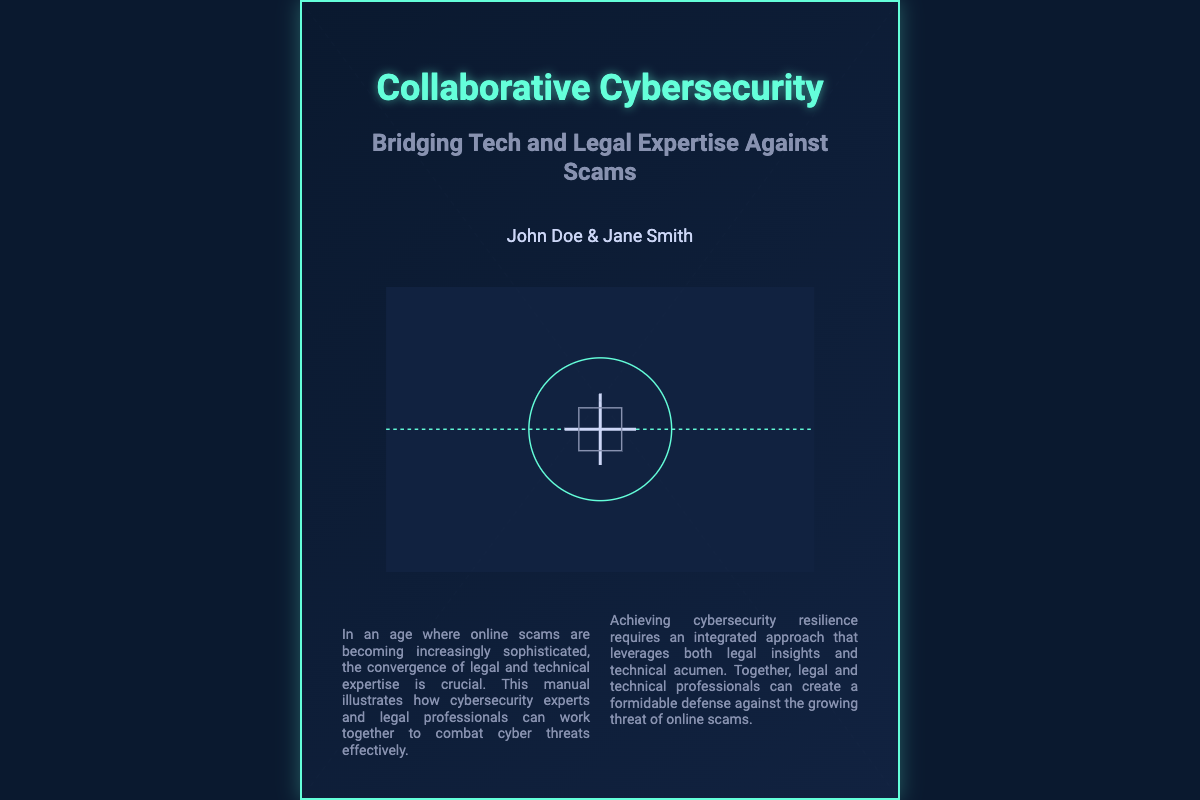What is the title of the book? The title is prominently displayed at the top of the book cover.
Answer: Collaborative Cybersecurity Who are the authors of the book? The authors' names are listed below the subtitle.
Answer: John Doe & Jane Smith What is the subtitle of the book? The subtitle provides additional context about the book's focus.
Answer: Bridging Tech and Legal Expertise Against Scams What visual elements are present on the book cover? The book cover features an illustration and background elements.
Answer: Handshake, interconnected networks, security padlocks What is the color of the border on the book cover? The border color is part of the visual design of the cover.
Answer: Light green What key concept does the book emphasize in combating scams? This concept is mentioned in the summary of the key aspects section.
Answer: Multi-disciplinary collaboration What is the height of the book cover in pixels? The height is specified in the dimensions of the cover design.
Answer: 800 pixels How many authors contributed to the book? The number of authors is indicated in the authors' section.
Answer: Two authors What background design element is included in the book cover? This element enhances the visual context of the book.
Answer: Network background 